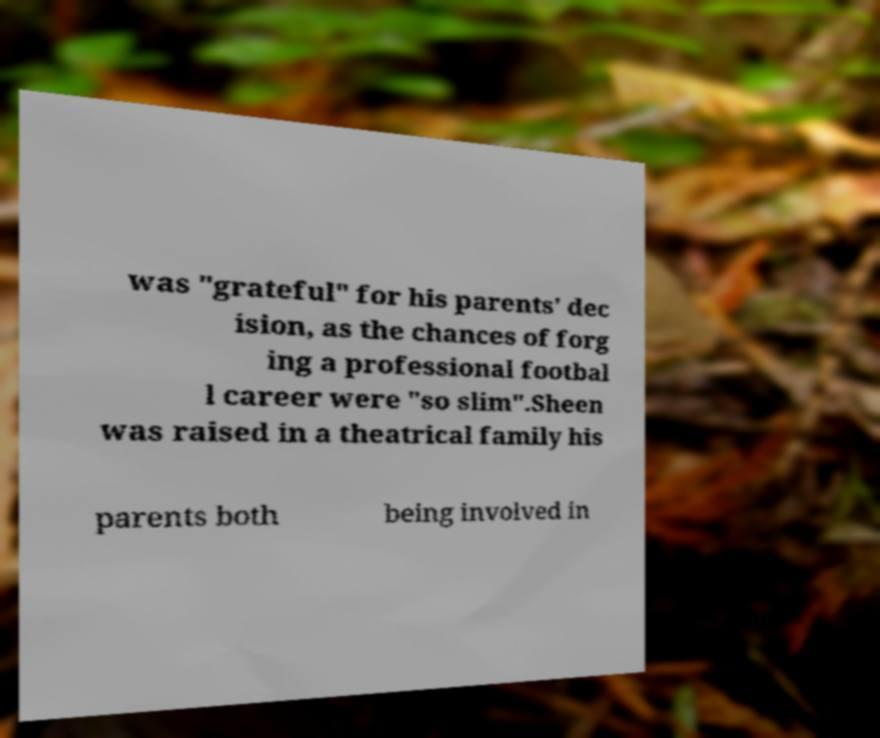Please identify and transcribe the text found in this image. was "grateful" for his parents' dec ision, as the chances of forg ing a professional footbal l career were "so slim".Sheen was raised in a theatrical family his parents both being involved in 